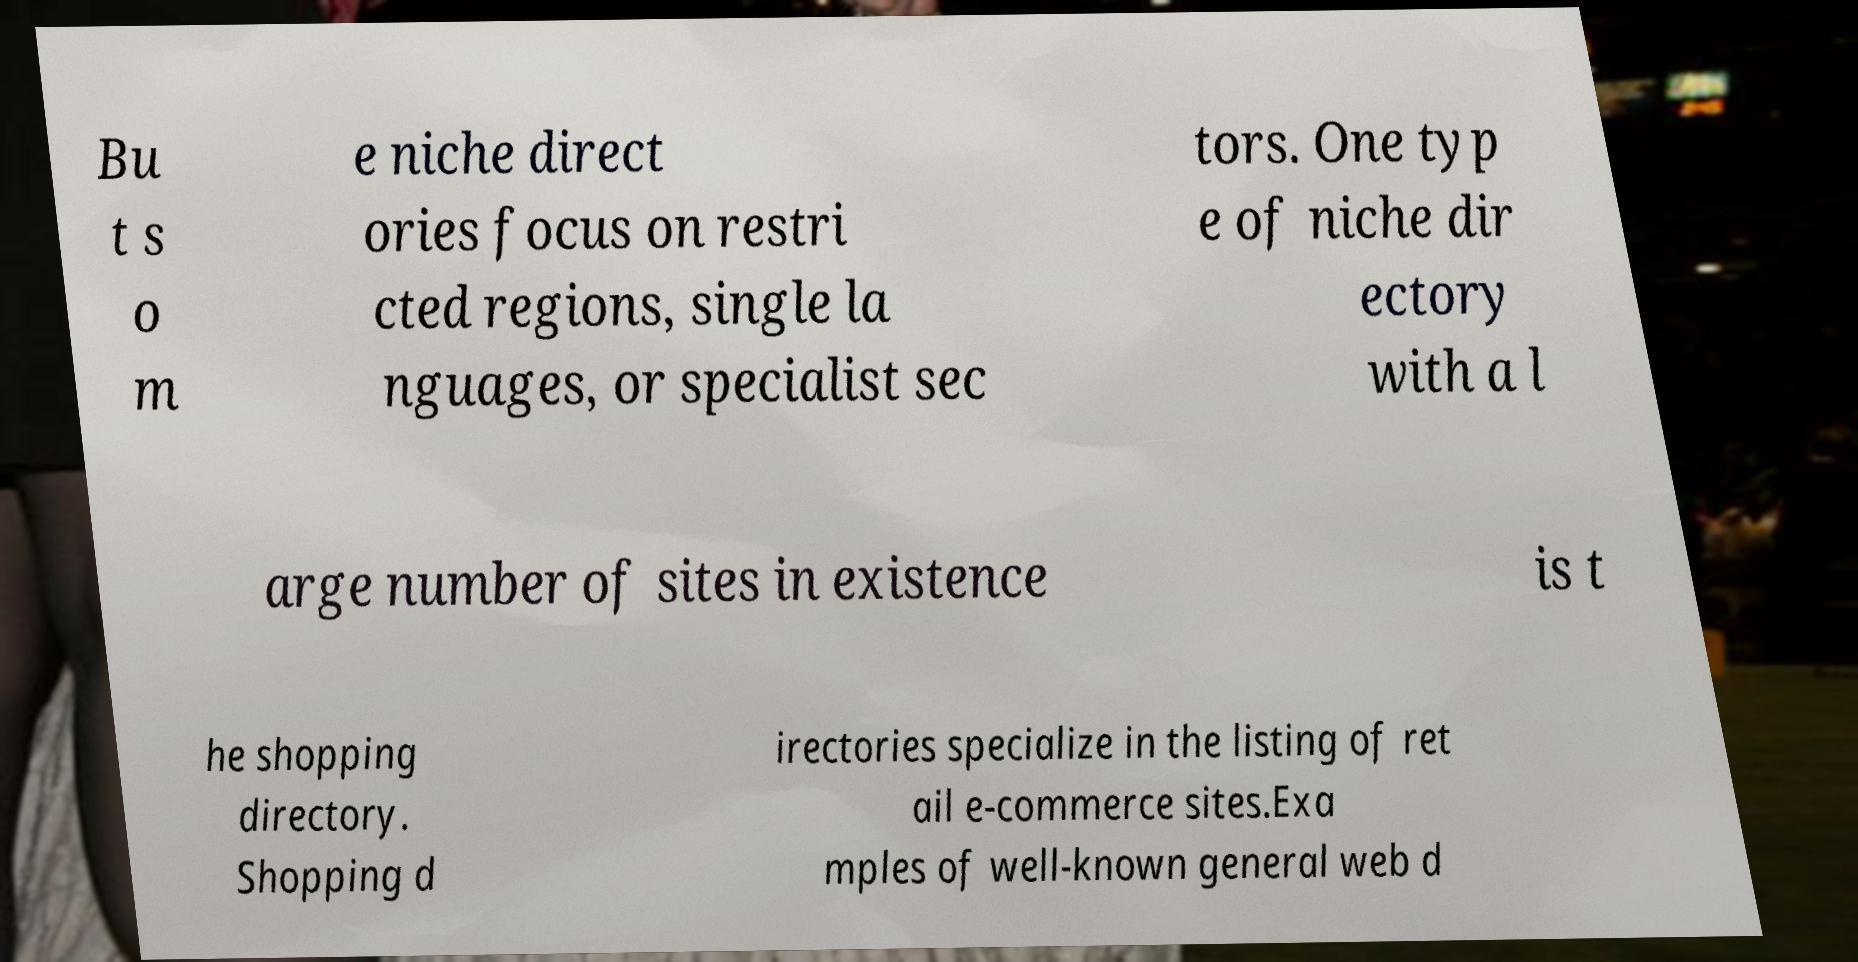Please read and relay the text visible in this image. What does it say? Bu t s o m e niche direct ories focus on restri cted regions, single la nguages, or specialist sec tors. One typ e of niche dir ectory with a l arge number of sites in existence is t he shopping directory. Shopping d irectories specialize in the listing of ret ail e-commerce sites.Exa mples of well-known general web d 